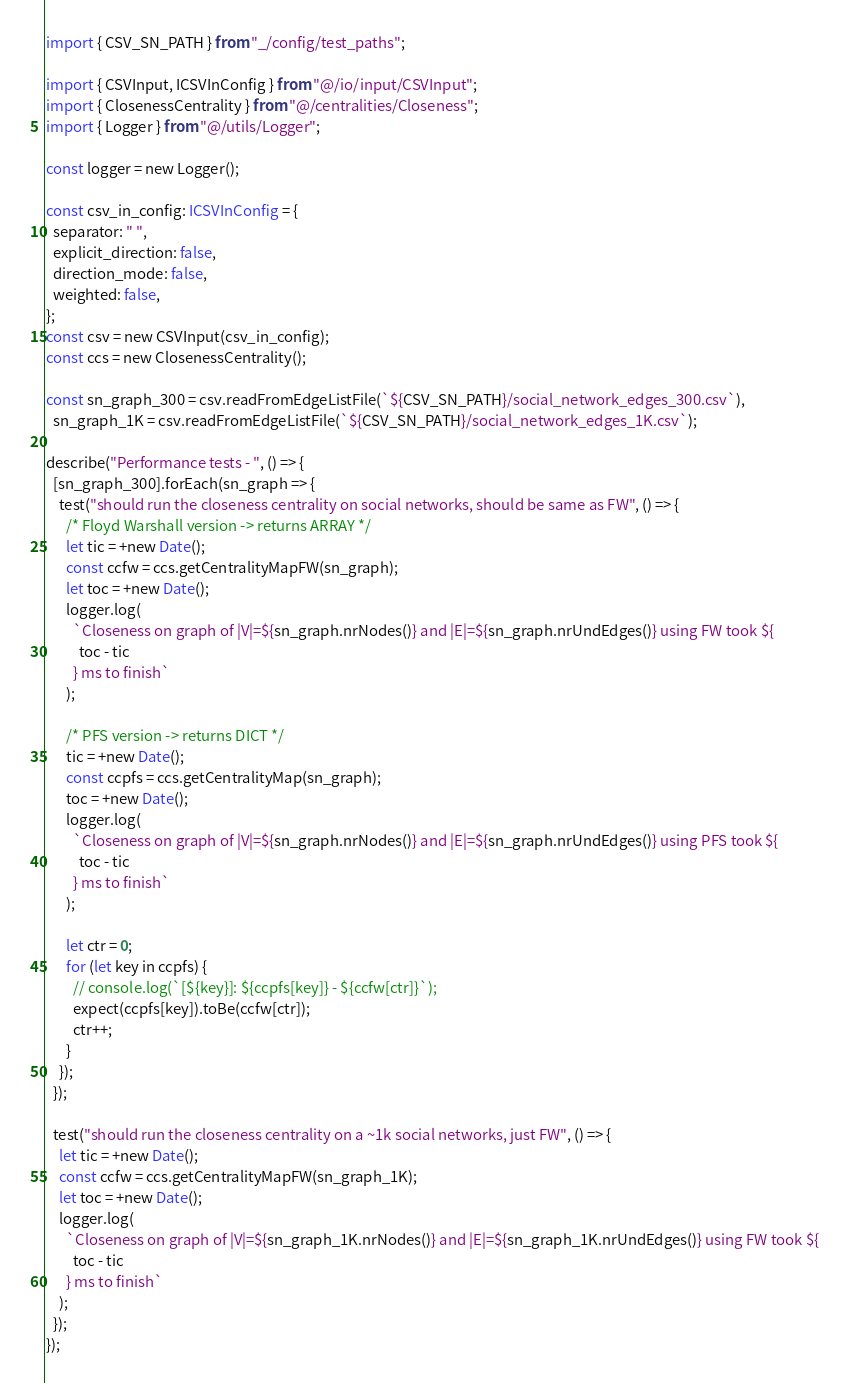Convert code to text. <code><loc_0><loc_0><loc_500><loc_500><_TypeScript_>import { CSV_SN_PATH } from "_/config/test_paths";

import { CSVInput, ICSVInConfig } from "@/io/input/CSVInput";
import { ClosenessCentrality } from "@/centralities/Closeness";
import { Logger } from "@/utils/Logger";

const logger = new Logger();

const csv_in_config: ICSVInConfig = {
  separator: " ",
  explicit_direction: false,
  direction_mode: false,
  weighted: false,
};
const csv = new CSVInput(csv_in_config);
const ccs = new ClosenessCentrality();

const sn_graph_300 = csv.readFromEdgeListFile(`${CSV_SN_PATH}/social_network_edges_300.csv`),
  sn_graph_1K = csv.readFromEdgeListFile(`${CSV_SN_PATH}/social_network_edges_1K.csv`);

describe("Performance tests - ", () => {
  [sn_graph_300].forEach(sn_graph => {
    test("should run the closeness centrality on social networks, should be same as FW", () => {
      /* Floyd Warshall version -> returns ARRAY */
      let tic = +new Date();
      const ccfw = ccs.getCentralityMapFW(sn_graph);
      let toc = +new Date();
      logger.log(
        `Closeness on graph of |V|=${sn_graph.nrNodes()} and |E|=${sn_graph.nrUndEdges()} using FW took ${
          toc - tic
        } ms to finish`
      );

      /* PFS version -> returns DICT */
      tic = +new Date();
      const ccpfs = ccs.getCentralityMap(sn_graph);
      toc = +new Date();
      logger.log(
        `Closeness on graph of |V|=${sn_graph.nrNodes()} and |E|=${sn_graph.nrUndEdges()} using PFS took ${
          toc - tic
        } ms to finish`
      );

      let ctr = 0;
      for (let key in ccpfs) {
        // console.log(`[${key}]: ${ccpfs[key]} - ${ccfw[ctr]}`);
        expect(ccpfs[key]).toBe(ccfw[ctr]);
        ctr++;
      }
    });
  });

  test("should run the closeness centrality on a ~1k social networks, just FW", () => {
    let tic = +new Date();
    const ccfw = ccs.getCentralityMapFW(sn_graph_1K);
    let toc = +new Date();
    logger.log(
      `Closeness on graph of |V|=${sn_graph_1K.nrNodes()} and |E|=${sn_graph_1K.nrUndEdges()} using FW took ${
        toc - tic
      } ms to finish`
    );
  });
});
</code> 